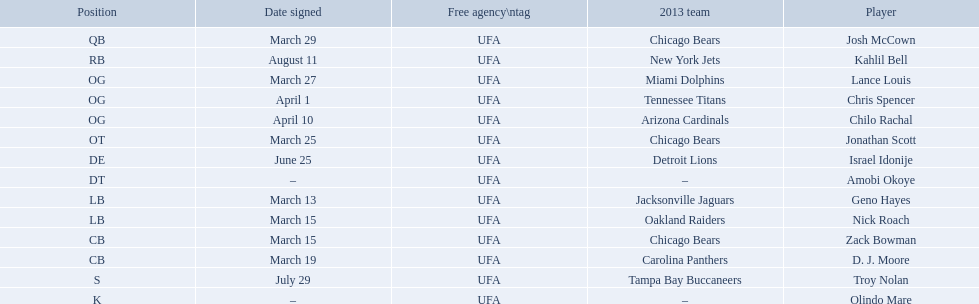Who are all of the players? Josh McCown, Kahlil Bell, Lance Louis, Chris Spencer, Chilo Rachal, Jonathan Scott, Israel Idonije, Amobi Okoye, Geno Hayes, Nick Roach, Zack Bowman, D. J. Moore, Troy Nolan, Olindo Mare. When were they signed? March 29, August 11, March 27, April 1, April 10, March 25, June 25, –, March 13, March 15, March 15, March 19, July 29, –. Along with nick roach, who else was signed on march 15? Zack Bowman. Who are all the players on the 2013 chicago bears season team? Josh McCown, Kahlil Bell, Lance Louis, Chris Spencer, Chilo Rachal, Jonathan Scott, Israel Idonije, Amobi Okoye, Geno Hayes, Nick Roach, Zack Bowman, D. J. Moore, Troy Nolan, Olindo Mare. What day was nick roach signed? March 15. What other day matches this? March 15. Who was signed on the day? Zack Bowman. 